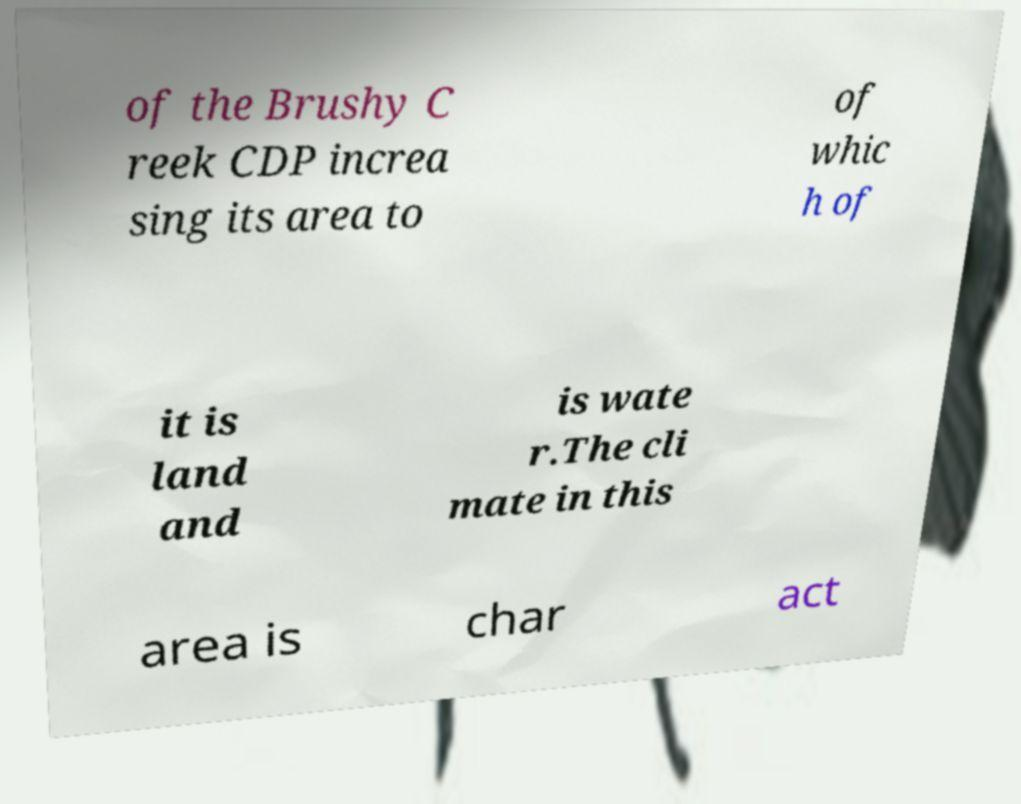Please identify and transcribe the text found in this image. of the Brushy C reek CDP increa sing its area to of whic h of it is land and is wate r.The cli mate in this area is char act 